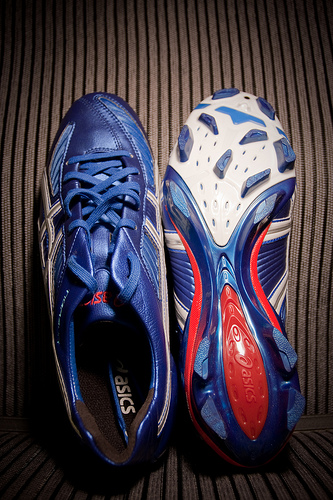<image>
Is there a right shoe in front of the left shoe? No. The right shoe is not in front of the left shoe. The spatial positioning shows a different relationship between these objects. 